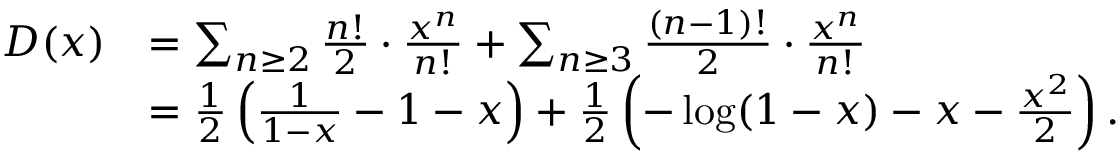<formula> <loc_0><loc_0><loc_500><loc_500>\begin{array} { r l } { D ( x ) } & { = \sum _ { n \geq 2 } \frac { n ! } { 2 } \cdot \frac { x ^ { n } } { n ! } + \sum _ { n \geq 3 } \frac { ( n - 1 ) ! } { 2 } \cdot \frac { x ^ { n } } { n ! } } \\ & { = \frac { 1 } { 2 } \left ( \frac { 1 } { 1 - x } - 1 - x \right ) + \frac { 1 } { 2 } \left ( - \log ( 1 - x ) - x - \frac { x ^ { 2 } } { 2 } \right ) . } \end{array}</formula> 